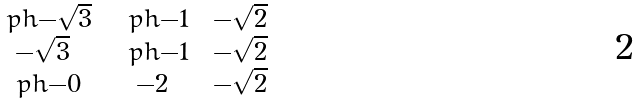<formula> <loc_0><loc_0><loc_500><loc_500>\begin{smallmatrix} \ p h { - } \sqrt { 3 } & \ \ p h { - } 1 & \ - \sqrt { 2 } \\ - \sqrt { 3 } & \ \ p h { - } 1 & \ - \sqrt { 2 } \\ \ p h { - } 0 & \ - 2 & \ - \sqrt { 2 } \end{smallmatrix}</formula> 